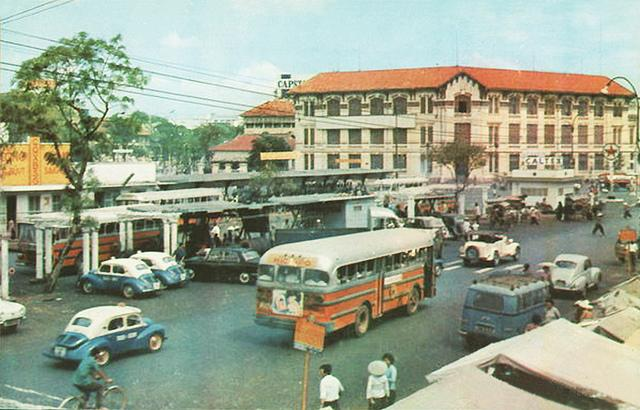What is the name of the gas station with the red star? Please explain your reasoning. caltex. The name can be seen on the sign. 